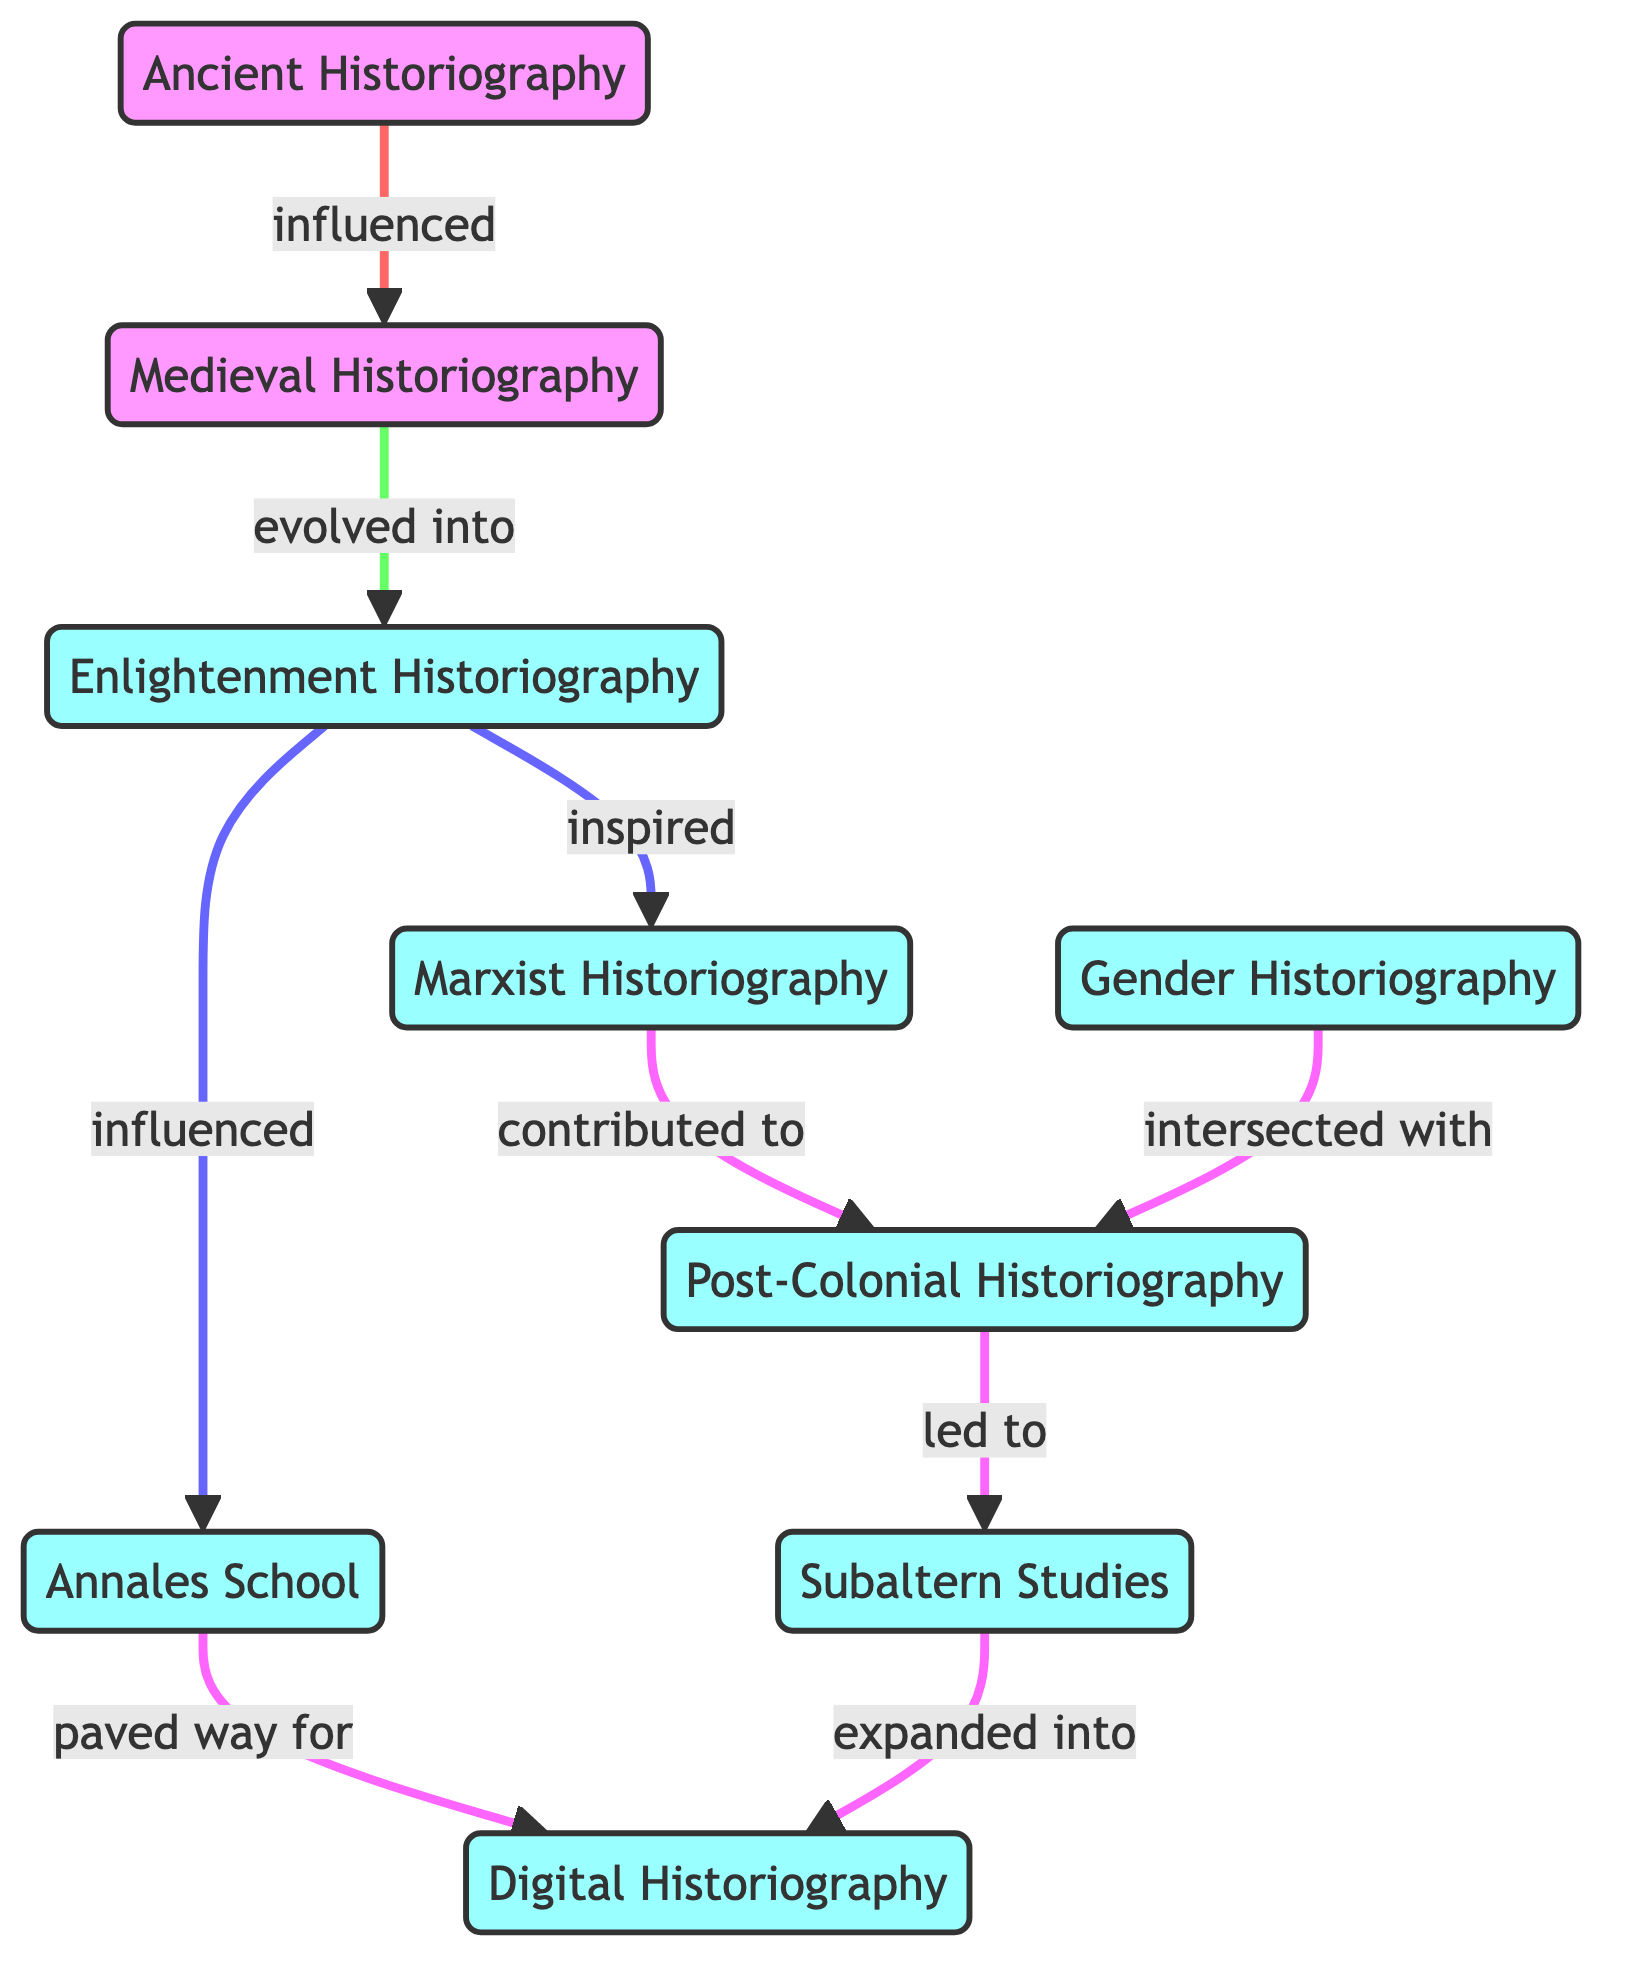What are the two major influences on Medieval Historiography? The diagram shows that Ancient Historiography influenced Medieval Historiography. Furthermore, Medieval Historiography evolved into Enlightenment Historiography, indicating it was also influenced by ideas that emerged in that later period.
Answer: Ancient Historiography, Enlightenment Historiography How many nodes are represented in the diagram? The diagram lists a total of 9 unique historical theories, which are the nodes in the directed graph. These are Ancient Historiography, Medieval Historiography, Enlightenment Historiography, Marxist Historiography, Annales School, Post-Colonial Historiography, Gender Historiography, Subaltern Studies, and Digital Historiography.
Answer: 9 Which historiography is connected to Digital Historiography? From the diagram, it's clear that both Annales School and Subaltern Studies lead to Digital Historiography, as indicated by their respective directed edges.
Answer: Annales School, Subaltern Studies What is the relationship between Enlightenment Historiography and Marxist Historiography? The diagram shows a directed edge from Enlightenment Historiography to Marxist Historiography, labeled "inspired". This indicates that Enlightenment theories had a significant impact on the development of Marxist historiographical approaches.
Answer: inspired What contributed to the development of Post-Colonial Historiography? The diagram indicates that Marxist Historiography directly contributed to the establishment of Post-Colonial Historiography, suggesting that ideas from Marxist analysis influenced its evolution.
Answer: contributed to Which historiographical approach evolved after Medieval Historiography? According to the diagram, Medieval Historiography evolved into Enlightenment Historiography, showcasing a progression from one period to another in historical thought.
Answer: Enlightenment Historiography What two historiographical approaches intersected? The directed edges in the diagram specifically show that Gender Historiography intersected with Post-Colonial Historiography, indicating a blending of methodologies and focuses in historical analysis.
Answer: Gender Historiography, Post-Colonial Historiography What is one major influence on Digital Historiography? The directed edge from Annales School to Digital Historiography indicates that Annales School paved the way for the development of Digital Historiography, showcasing the transition to contemporary methods.
Answer: paved way for What do the edges in the directed graph represent? The edges in the directed graph represent the relationships and influences between different historiographical approaches, indicating how they have evolved or contributed to one another over time.
Answer: relationships and influences 